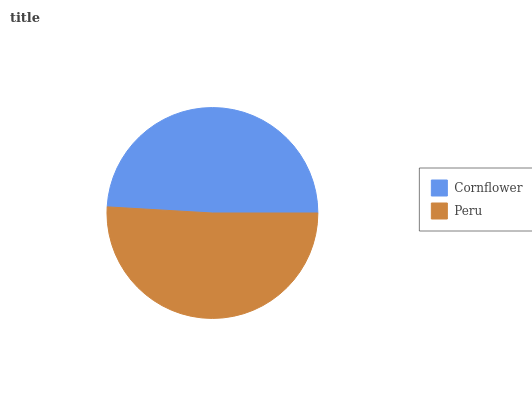Is Cornflower the minimum?
Answer yes or no. Yes. Is Peru the maximum?
Answer yes or no. Yes. Is Peru the minimum?
Answer yes or no. No. Is Peru greater than Cornflower?
Answer yes or no. Yes. Is Cornflower less than Peru?
Answer yes or no. Yes. Is Cornflower greater than Peru?
Answer yes or no. No. Is Peru less than Cornflower?
Answer yes or no. No. Is Peru the high median?
Answer yes or no. Yes. Is Cornflower the low median?
Answer yes or no. Yes. Is Cornflower the high median?
Answer yes or no. No. Is Peru the low median?
Answer yes or no. No. 